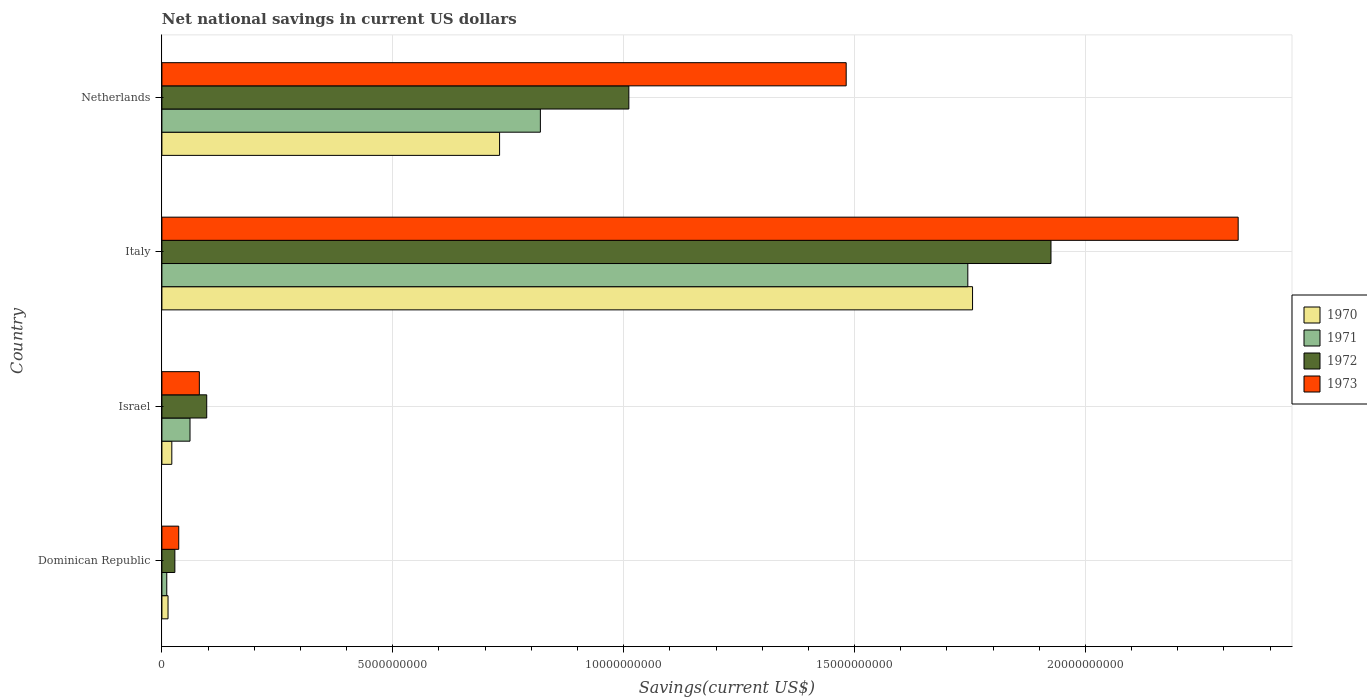How many different coloured bars are there?
Ensure brevity in your answer.  4. How many groups of bars are there?
Offer a very short reply. 4. Are the number of bars on each tick of the Y-axis equal?
Make the answer very short. Yes. How many bars are there on the 4th tick from the top?
Keep it short and to the point. 4. How many bars are there on the 4th tick from the bottom?
Provide a short and direct response. 4. What is the label of the 1st group of bars from the top?
Provide a succinct answer. Netherlands. In how many cases, is the number of bars for a given country not equal to the number of legend labels?
Your answer should be very brief. 0. What is the net national savings in 1971 in Dominican Republic?
Your response must be concise. 1.05e+08. Across all countries, what is the maximum net national savings in 1970?
Make the answer very short. 1.76e+1. Across all countries, what is the minimum net national savings in 1972?
Give a very brief answer. 2.80e+08. In which country was the net national savings in 1973 minimum?
Ensure brevity in your answer.  Dominican Republic. What is the total net national savings in 1972 in the graph?
Your answer should be very brief. 3.06e+1. What is the difference between the net national savings in 1973 in Dominican Republic and that in Netherlands?
Give a very brief answer. -1.45e+1. What is the difference between the net national savings in 1971 in Dominican Republic and the net national savings in 1973 in Netherlands?
Provide a succinct answer. -1.47e+1. What is the average net national savings in 1971 per country?
Ensure brevity in your answer.  6.59e+09. What is the difference between the net national savings in 1970 and net national savings in 1972 in Dominican Republic?
Offer a very short reply. -1.48e+08. In how many countries, is the net national savings in 1973 greater than 15000000000 US$?
Your answer should be compact. 1. What is the ratio of the net national savings in 1972 in Dominican Republic to that in Italy?
Your response must be concise. 0.01. Is the difference between the net national savings in 1970 in Dominican Republic and Italy greater than the difference between the net national savings in 1972 in Dominican Republic and Italy?
Provide a short and direct response. Yes. What is the difference between the highest and the second highest net national savings in 1972?
Your answer should be compact. 9.14e+09. What is the difference between the highest and the lowest net national savings in 1971?
Offer a terse response. 1.73e+1. In how many countries, is the net national savings in 1970 greater than the average net national savings in 1970 taken over all countries?
Offer a very short reply. 2. Is the sum of the net national savings in 1972 in Israel and Netherlands greater than the maximum net national savings in 1973 across all countries?
Provide a succinct answer. No. What does the 3rd bar from the top in Netherlands represents?
Ensure brevity in your answer.  1971. What does the 3rd bar from the bottom in Israel represents?
Offer a very short reply. 1972. Is it the case that in every country, the sum of the net national savings in 1970 and net national savings in 1971 is greater than the net national savings in 1973?
Your response must be concise. No. How many countries are there in the graph?
Provide a short and direct response. 4. Does the graph contain any zero values?
Make the answer very short. No. Where does the legend appear in the graph?
Your response must be concise. Center right. How are the legend labels stacked?
Offer a very short reply. Vertical. What is the title of the graph?
Give a very brief answer. Net national savings in current US dollars. Does "1988" appear as one of the legend labels in the graph?
Keep it short and to the point. No. What is the label or title of the X-axis?
Your answer should be very brief. Savings(current US$). What is the Savings(current US$) of 1970 in Dominican Republic?
Your answer should be very brief. 1.33e+08. What is the Savings(current US$) of 1971 in Dominican Republic?
Provide a succinct answer. 1.05e+08. What is the Savings(current US$) in 1972 in Dominican Republic?
Make the answer very short. 2.80e+08. What is the Savings(current US$) in 1973 in Dominican Republic?
Make the answer very short. 3.65e+08. What is the Savings(current US$) of 1970 in Israel?
Ensure brevity in your answer.  2.15e+08. What is the Savings(current US$) of 1971 in Israel?
Your answer should be very brief. 6.09e+08. What is the Savings(current US$) in 1972 in Israel?
Your answer should be compact. 9.71e+08. What is the Savings(current US$) of 1973 in Israel?
Offer a very short reply. 8.11e+08. What is the Savings(current US$) in 1970 in Italy?
Make the answer very short. 1.76e+1. What is the Savings(current US$) of 1971 in Italy?
Offer a very short reply. 1.75e+1. What is the Savings(current US$) of 1972 in Italy?
Give a very brief answer. 1.93e+1. What is the Savings(current US$) in 1973 in Italy?
Offer a terse response. 2.33e+1. What is the Savings(current US$) in 1970 in Netherlands?
Keep it short and to the point. 7.31e+09. What is the Savings(current US$) in 1971 in Netherlands?
Make the answer very short. 8.20e+09. What is the Savings(current US$) of 1972 in Netherlands?
Your response must be concise. 1.01e+1. What is the Savings(current US$) in 1973 in Netherlands?
Ensure brevity in your answer.  1.48e+1. Across all countries, what is the maximum Savings(current US$) in 1970?
Your answer should be compact. 1.76e+1. Across all countries, what is the maximum Savings(current US$) in 1971?
Offer a terse response. 1.75e+1. Across all countries, what is the maximum Savings(current US$) in 1972?
Your answer should be very brief. 1.93e+1. Across all countries, what is the maximum Savings(current US$) of 1973?
Give a very brief answer. 2.33e+1. Across all countries, what is the minimum Savings(current US$) of 1970?
Make the answer very short. 1.33e+08. Across all countries, what is the minimum Savings(current US$) in 1971?
Offer a very short reply. 1.05e+08. Across all countries, what is the minimum Savings(current US$) of 1972?
Offer a very short reply. 2.80e+08. Across all countries, what is the minimum Savings(current US$) in 1973?
Ensure brevity in your answer.  3.65e+08. What is the total Savings(current US$) in 1970 in the graph?
Make the answer very short. 2.52e+1. What is the total Savings(current US$) of 1971 in the graph?
Keep it short and to the point. 2.64e+1. What is the total Savings(current US$) of 1972 in the graph?
Ensure brevity in your answer.  3.06e+1. What is the total Savings(current US$) in 1973 in the graph?
Ensure brevity in your answer.  3.93e+1. What is the difference between the Savings(current US$) of 1970 in Dominican Republic and that in Israel?
Your response must be concise. -8.19e+07. What is the difference between the Savings(current US$) in 1971 in Dominican Republic and that in Israel?
Offer a very short reply. -5.03e+08. What is the difference between the Savings(current US$) in 1972 in Dominican Republic and that in Israel?
Ensure brevity in your answer.  -6.90e+08. What is the difference between the Savings(current US$) in 1973 in Dominican Republic and that in Israel?
Offer a very short reply. -4.46e+08. What is the difference between the Savings(current US$) of 1970 in Dominican Republic and that in Italy?
Offer a terse response. -1.74e+1. What is the difference between the Savings(current US$) of 1971 in Dominican Republic and that in Italy?
Offer a very short reply. -1.73e+1. What is the difference between the Savings(current US$) of 1972 in Dominican Republic and that in Italy?
Keep it short and to the point. -1.90e+1. What is the difference between the Savings(current US$) in 1973 in Dominican Republic and that in Italy?
Offer a very short reply. -2.29e+1. What is the difference between the Savings(current US$) of 1970 in Dominican Republic and that in Netherlands?
Make the answer very short. -7.18e+09. What is the difference between the Savings(current US$) of 1971 in Dominican Republic and that in Netherlands?
Offer a very short reply. -8.09e+09. What is the difference between the Savings(current US$) of 1972 in Dominican Republic and that in Netherlands?
Provide a succinct answer. -9.83e+09. What is the difference between the Savings(current US$) of 1973 in Dominican Republic and that in Netherlands?
Provide a succinct answer. -1.45e+1. What is the difference between the Savings(current US$) in 1970 in Israel and that in Italy?
Your answer should be compact. -1.73e+1. What is the difference between the Savings(current US$) in 1971 in Israel and that in Italy?
Your answer should be very brief. -1.68e+1. What is the difference between the Savings(current US$) of 1972 in Israel and that in Italy?
Make the answer very short. -1.83e+1. What is the difference between the Savings(current US$) of 1973 in Israel and that in Italy?
Offer a very short reply. -2.25e+1. What is the difference between the Savings(current US$) of 1970 in Israel and that in Netherlands?
Offer a terse response. -7.10e+09. What is the difference between the Savings(current US$) of 1971 in Israel and that in Netherlands?
Your answer should be very brief. -7.59e+09. What is the difference between the Savings(current US$) of 1972 in Israel and that in Netherlands?
Give a very brief answer. -9.14e+09. What is the difference between the Savings(current US$) in 1973 in Israel and that in Netherlands?
Offer a terse response. -1.40e+1. What is the difference between the Savings(current US$) in 1970 in Italy and that in Netherlands?
Provide a short and direct response. 1.02e+1. What is the difference between the Savings(current US$) in 1971 in Italy and that in Netherlands?
Keep it short and to the point. 9.26e+09. What is the difference between the Savings(current US$) in 1972 in Italy and that in Netherlands?
Your answer should be very brief. 9.14e+09. What is the difference between the Savings(current US$) in 1973 in Italy and that in Netherlands?
Keep it short and to the point. 8.49e+09. What is the difference between the Savings(current US$) of 1970 in Dominican Republic and the Savings(current US$) of 1971 in Israel?
Your answer should be compact. -4.76e+08. What is the difference between the Savings(current US$) in 1970 in Dominican Republic and the Savings(current US$) in 1972 in Israel?
Your response must be concise. -8.38e+08. What is the difference between the Savings(current US$) in 1970 in Dominican Republic and the Savings(current US$) in 1973 in Israel?
Offer a terse response. -6.78e+08. What is the difference between the Savings(current US$) in 1971 in Dominican Republic and the Savings(current US$) in 1972 in Israel?
Keep it short and to the point. -8.65e+08. What is the difference between the Savings(current US$) of 1971 in Dominican Republic and the Savings(current US$) of 1973 in Israel?
Make the answer very short. -7.05e+08. What is the difference between the Savings(current US$) of 1972 in Dominican Republic and the Savings(current US$) of 1973 in Israel?
Provide a short and direct response. -5.30e+08. What is the difference between the Savings(current US$) of 1970 in Dominican Republic and the Savings(current US$) of 1971 in Italy?
Offer a terse response. -1.73e+1. What is the difference between the Savings(current US$) in 1970 in Dominican Republic and the Savings(current US$) in 1972 in Italy?
Your answer should be compact. -1.91e+1. What is the difference between the Savings(current US$) in 1970 in Dominican Republic and the Savings(current US$) in 1973 in Italy?
Keep it short and to the point. -2.32e+1. What is the difference between the Savings(current US$) of 1971 in Dominican Republic and the Savings(current US$) of 1972 in Italy?
Give a very brief answer. -1.91e+1. What is the difference between the Savings(current US$) in 1971 in Dominican Republic and the Savings(current US$) in 1973 in Italy?
Offer a very short reply. -2.32e+1. What is the difference between the Savings(current US$) of 1972 in Dominican Republic and the Savings(current US$) of 1973 in Italy?
Your answer should be compact. -2.30e+1. What is the difference between the Savings(current US$) of 1970 in Dominican Republic and the Savings(current US$) of 1971 in Netherlands?
Your answer should be very brief. -8.06e+09. What is the difference between the Savings(current US$) of 1970 in Dominican Republic and the Savings(current US$) of 1972 in Netherlands?
Offer a very short reply. -9.98e+09. What is the difference between the Savings(current US$) of 1970 in Dominican Republic and the Savings(current US$) of 1973 in Netherlands?
Your answer should be compact. -1.47e+1. What is the difference between the Savings(current US$) of 1971 in Dominican Republic and the Savings(current US$) of 1972 in Netherlands?
Offer a terse response. -1.00e+1. What is the difference between the Savings(current US$) of 1971 in Dominican Republic and the Savings(current US$) of 1973 in Netherlands?
Give a very brief answer. -1.47e+1. What is the difference between the Savings(current US$) in 1972 in Dominican Republic and the Savings(current US$) in 1973 in Netherlands?
Offer a very short reply. -1.45e+1. What is the difference between the Savings(current US$) of 1970 in Israel and the Savings(current US$) of 1971 in Italy?
Provide a succinct answer. -1.72e+1. What is the difference between the Savings(current US$) in 1970 in Israel and the Savings(current US$) in 1972 in Italy?
Your answer should be compact. -1.90e+1. What is the difference between the Savings(current US$) in 1970 in Israel and the Savings(current US$) in 1973 in Italy?
Your response must be concise. -2.31e+1. What is the difference between the Savings(current US$) in 1971 in Israel and the Savings(current US$) in 1972 in Italy?
Offer a terse response. -1.86e+1. What is the difference between the Savings(current US$) of 1971 in Israel and the Savings(current US$) of 1973 in Italy?
Make the answer very short. -2.27e+1. What is the difference between the Savings(current US$) of 1972 in Israel and the Savings(current US$) of 1973 in Italy?
Provide a short and direct response. -2.23e+1. What is the difference between the Savings(current US$) of 1970 in Israel and the Savings(current US$) of 1971 in Netherlands?
Provide a succinct answer. -7.98e+09. What is the difference between the Savings(current US$) of 1970 in Israel and the Savings(current US$) of 1972 in Netherlands?
Provide a short and direct response. -9.90e+09. What is the difference between the Savings(current US$) of 1970 in Israel and the Savings(current US$) of 1973 in Netherlands?
Offer a very short reply. -1.46e+1. What is the difference between the Savings(current US$) of 1971 in Israel and the Savings(current US$) of 1972 in Netherlands?
Provide a short and direct response. -9.50e+09. What is the difference between the Savings(current US$) in 1971 in Israel and the Savings(current US$) in 1973 in Netherlands?
Keep it short and to the point. -1.42e+1. What is the difference between the Savings(current US$) of 1972 in Israel and the Savings(current US$) of 1973 in Netherlands?
Ensure brevity in your answer.  -1.38e+1. What is the difference between the Savings(current US$) of 1970 in Italy and the Savings(current US$) of 1971 in Netherlands?
Provide a short and direct response. 9.36e+09. What is the difference between the Savings(current US$) in 1970 in Italy and the Savings(current US$) in 1972 in Netherlands?
Ensure brevity in your answer.  7.44e+09. What is the difference between the Savings(current US$) of 1970 in Italy and the Savings(current US$) of 1973 in Netherlands?
Keep it short and to the point. 2.74e+09. What is the difference between the Savings(current US$) of 1971 in Italy and the Savings(current US$) of 1972 in Netherlands?
Provide a succinct answer. 7.34e+09. What is the difference between the Savings(current US$) of 1971 in Italy and the Savings(current US$) of 1973 in Netherlands?
Your answer should be very brief. 2.63e+09. What is the difference between the Savings(current US$) of 1972 in Italy and the Savings(current US$) of 1973 in Netherlands?
Provide a short and direct response. 4.44e+09. What is the average Savings(current US$) of 1970 per country?
Your answer should be very brief. 6.30e+09. What is the average Savings(current US$) of 1971 per country?
Give a very brief answer. 6.59e+09. What is the average Savings(current US$) in 1972 per country?
Offer a very short reply. 7.65e+09. What is the average Savings(current US$) of 1973 per country?
Ensure brevity in your answer.  9.83e+09. What is the difference between the Savings(current US$) of 1970 and Savings(current US$) of 1971 in Dominican Republic?
Make the answer very short. 2.74e+07. What is the difference between the Savings(current US$) in 1970 and Savings(current US$) in 1972 in Dominican Republic?
Ensure brevity in your answer.  -1.48e+08. What is the difference between the Savings(current US$) of 1970 and Savings(current US$) of 1973 in Dominican Republic?
Give a very brief answer. -2.32e+08. What is the difference between the Savings(current US$) in 1971 and Savings(current US$) in 1972 in Dominican Republic?
Offer a terse response. -1.75e+08. What is the difference between the Savings(current US$) of 1971 and Savings(current US$) of 1973 in Dominican Republic?
Offer a terse response. -2.59e+08. What is the difference between the Savings(current US$) in 1972 and Savings(current US$) in 1973 in Dominican Republic?
Keep it short and to the point. -8.40e+07. What is the difference between the Savings(current US$) of 1970 and Savings(current US$) of 1971 in Israel?
Give a very brief answer. -3.94e+08. What is the difference between the Savings(current US$) of 1970 and Savings(current US$) of 1972 in Israel?
Keep it short and to the point. -7.56e+08. What is the difference between the Savings(current US$) of 1970 and Savings(current US$) of 1973 in Israel?
Offer a terse response. -5.96e+08. What is the difference between the Savings(current US$) of 1971 and Savings(current US$) of 1972 in Israel?
Make the answer very short. -3.62e+08. What is the difference between the Savings(current US$) in 1971 and Savings(current US$) in 1973 in Israel?
Provide a succinct answer. -2.02e+08. What is the difference between the Savings(current US$) of 1972 and Savings(current US$) of 1973 in Israel?
Ensure brevity in your answer.  1.60e+08. What is the difference between the Savings(current US$) in 1970 and Savings(current US$) in 1971 in Italy?
Make the answer very short. 1.03e+08. What is the difference between the Savings(current US$) of 1970 and Savings(current US$) of 1972 in Italy?
Your answer should be compact. -1.70e+09. What is the difference between the Savings(current US$) of 1970 and Savings(current US$) of 1973 in Italy?
Provide a short and direct response. -5.75e+09. What is the difference between the Savings(current US$) of 1971 and Savings(current US$) of 1972 in Italy?
Offer a terse response. -1.80e+09. What is the difference between the Savings(current US$) of 1971 and Savings(current US$) of 1973 in Italy?
Give a very brief answer. -5.86e+09. What is the difference between the Savings(current US$) in 1972 and Savings(current US$) in 1973 in Italy?
Offer a very short reply. -4.05e+09. What is the difference between the Savings(current US$) of 1970 and Savings(current US$) of 1971 in Netherlands?
Ensure brevity in your answer.  -8.83e+08. What is the difference between the Savings(current US$) in 1970 and Savings(current US$) in 1972 in Netherlands?
Provide a succinct answer. -2.80e+09. What is the difference between the Savings(current US$) of 1970 and Savings(current US$) of 1973 in Netherlands?
Your answer should be very brief. -7.51e+09. What is the difference between the Savings(current US$) in 1971 and Savings(current US$) in 1972 in Netherlands?
Provide a short and direct response. -1.92e+09. What is the difference between the Savings(current US$) in 1971 and Savings(current US$) in 1973 in Netherlands?
Provide a succinct answer. -6.62e+09. What is the difference between the Savings(current US$) of 1972 and Savings(current US$) of 1973 in Netherlands?
Your answer should be very brief. -4.71e+09. What is the ratio of the Savings(current US$) in 1970 in Dominican Republic to that in Israel?
Keep it short and to the point. 0.62. What is the ratio of the Savings(current US$) in 1971 in Dominican Republic to that in Israel?
Your answer should be compact. 0.17. What is the ratio of the Savings(current US$) of 1972 in Dominican Republic to that in Israel?
Make the answer very short. 0.29. What is the ratio of the Savings(current US$) in 1973 in Dominican Republic to that in Israel?
Your answer should be compact. 0.45. What is the ratio of the Savings(current US$) of 1970 in Dominican Republic to that in Italy?
Your answer should be very brief. 0.01. What is the ratio of the Savings(current US$) of 1971 in Dominican Republic to that in Italy?
Keep it short and to the point. 0.01. What is the ratio of the Savings(current US$) of 1972 in Dominican Republic to that in Italy?
Your response must be concise. 0.01. What is the ratio of the Savings(current US$) in 1973 in Dominican Republic to that in Italy?
Your answer should be compact. 0.02. What is the ratio of the Savings(current US$) in 1970 in Dominican Republic to that in Netherlands?
Your answer should be very brief. 0.02. What is the ratio of the Savings(current US$) of 1971 in Dominican Republic to that in Netherlands?
Your response must be concise. 0.01. What is the ratio of the Savings(current US$) of 1972 in Dominican Republic to that in Netherlands?
Keep it short and to the point. 0.03. What is the ratio of the Savings(current US$) in 1973 in Dominican Republic to that in Netherlands?
Your answer should be compact. 0.02. What is the ratio of the Savings(current US$) of 1970 in Israel to that in Italy?
Your answer should be compact. 0.01. What is the ratio of the Savings(current US$) of 1971 in Israel to that in Italy?
Make the answer very short. 0.03. What is the ratio of the Savings(current US$) in 1972 in Israel to that in Italy?
Your response must be concise. 0.05. What is the ratio of the Savings(current US$) of 1973 in Israel to that in Italy?
Ensure brevity in your answer.  0.03. What is the ratio of the Savings(current US$) in 1970 in Israel to that in Netherlands?
Your answer should be very brief. 0.03. What is the ratio of the Savings(current US$) in 1971 in Israel to that in Netherlands?
Ensure brevity in your answer.  0.07. What is the ratio of the Savings(current US$) in 1972 in Israel to that in Netherlands?
Your response must be concise. 0.1. What is the ratio of the Savings(current US$) of 1973 in Israel to that in Netherlands?
Make the answer very short. 0.05. What is the ratio of the Savings(current US$) of 1970 in Italy to that in Netherlands?
Ensure brevity in your answer.  2.4. What is the ratio of the Savings(current US$) of 1971 in Italy to that in Netherlands?
Your answer should be compact. 2.13. What is the ratio of the Savings(current US$) in 1972 in Italy to that in Netherlands?
Offer a terse response. 1.9. What is the ratio of the Savings(current US$) in 1973 in Italy to that in Netherlands?
Give a very brief answer. 1.57. What is the difference between the highest and the second highest Savings(current US$) of 1970?
Provide a short and direct response. 1.02e+1. What is the difference between the highest and the second highest Savings(current US$) in 1971?
Your answer should be very brief. 9.26e+09. What is the difference between the highest and the second highest Savings(current US$) in 1972?
Offer a very short reply. 9.14e+09. What is the difference between the highest and the second highest Savings(current US$) in 1973?
Your answer should be compact. 8.49e+09. What is the difference between the highest and the lowest Savings(current US$) of 1970?
Ensure brevity in your answer.  1.74e+1. What is the difference between the highest and the lowest Savings(current US$) in 1971?
Keep it short and to the point. 1.73e+1. What is the difference between the highest and the lowest Savings(current US$) in 1972?
Make the answer very short. 1.90e+1. What is the difference between the highest and the lowest Savings(current US$) of 1973?
Your answer should be very brief. 2.29e+1. 